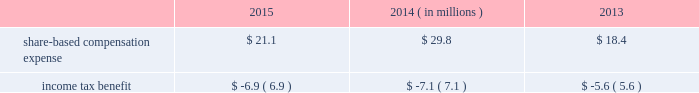During fiscal 2013 , we entered into an asr with a financial institution to repurchase an aggregate of $ 125 million of our common stock .
In exchange for an up-front payment of $ 125 million , the financial institution committed to deliver a number of shares during the asr 2019s purchase period , which ended on march 30 , 2013 .
The total number of shares delivered under this asr was 2.5 million at an average price of $ 49.13 per share .
During fiscal 2013 , in addition to shares repurchased under the asr , we repurchased and retired 1.1 million shares of our common stock at a cost of $ 50.3 million , or an average of $ 44.55 per share , including commissions .
Note 10 2014share-based awards and options non-qualified stock options and restricted stock have been granted to officers , key employees and directors under the global payments inc .
2000 long-term incentive plan , as amended and restated ( the 201c2000 plan 201d ) , the global payments inc .
Amended and restated 2005 incentive plan ( the 201c2005 plan 201d ) , the amended and restated 2000 non-employee director stock option plan ( the 201cdirector stock option plan 201d ) , and the global payments inc .
2011 incentive plan ( the 201c2011 plan 201d ) ( collectively , the 201cplans 201d ) .
There were no further grants made under the 2000 plan after the 2005 plan was effective , and the director stock option plan expired by its terms on february 1 , 2011 .
There will be no future grants under the 2000 plan , the 2005 plan or the director stock option the 2011 plan permits grants of equity to employees , officers , directors and consultants .
A total of 7.0 million shares of our common stock was reserved and made available for issuance pursuant to awards granted under the 2011 plan .
The table summarizes share-based compensation expense and the related income tax benefit recognized for stock options , restricted stock , performance units , tsr units , and shares issued under our employee stock purchase plan ( each as described below ) .
2015 2014 2013 ( in millions ) .
We grant various share-based awards pursuant to the plans under what we refer to as our 201clong-term incentive plan . 201d the awards are held in escrow and released upon the grantee 2019s satisfaction of conditions of the award certificate .
Restricted stock and restricted stock units we grant restricted stock and restricted stock units .
Restricted stock awards vest over a period of time , provided , however , that if the grantee is not employed by us on the vesting date , the shares are forfeited .
Restricted shares cannot be sold or transferred until they have vested .
Restricted stock granted before fiscal 2015 vests in equal installments on each of the first four anniversaries of the grant date .
Restricted stock granted during fiscal 2015 will either vest in equal installments on each of the first three anniversaries of the grant date or cliff vest at the end of a three-year service period .
The grant date fair value of restricted stock , which is based on the quoted market value of our common stock at the closing of the award date , is recognized as share-based compensation expense on a straight-line basis over the vesting period .
Performance units certain of our executives have been granted up to three types of performance units under our long-term incentive plan .
Performance units are performance-based restricted stock units that , after a performance period , convert into common shares , which may be restricted .
The number of shares is dependent upon the achievement of certain performance measures during the performance period .
The target number of performance units and any market-based performance measures ( 201cat threshold , 201d 201ctarget , 201d and 201cmaximum 201d ) are set by the compensation committee of our board of directors .
Performance units are converted only after the compensation committee certifies performance based on pre-established goals .
80 2013 global payments inc .
| 2015 form 10-k annual report .
What was the total income tax benefit that came from buying back their common stock from 2013 to 2015? 
Rationale: to calculate the income tax benefit one would need to add up the income tax benefit for the years of 2013 , 2014 , and 2015 .
Computations: (5.6 + (6.9 + 7.1))
Answer: 19.6. 